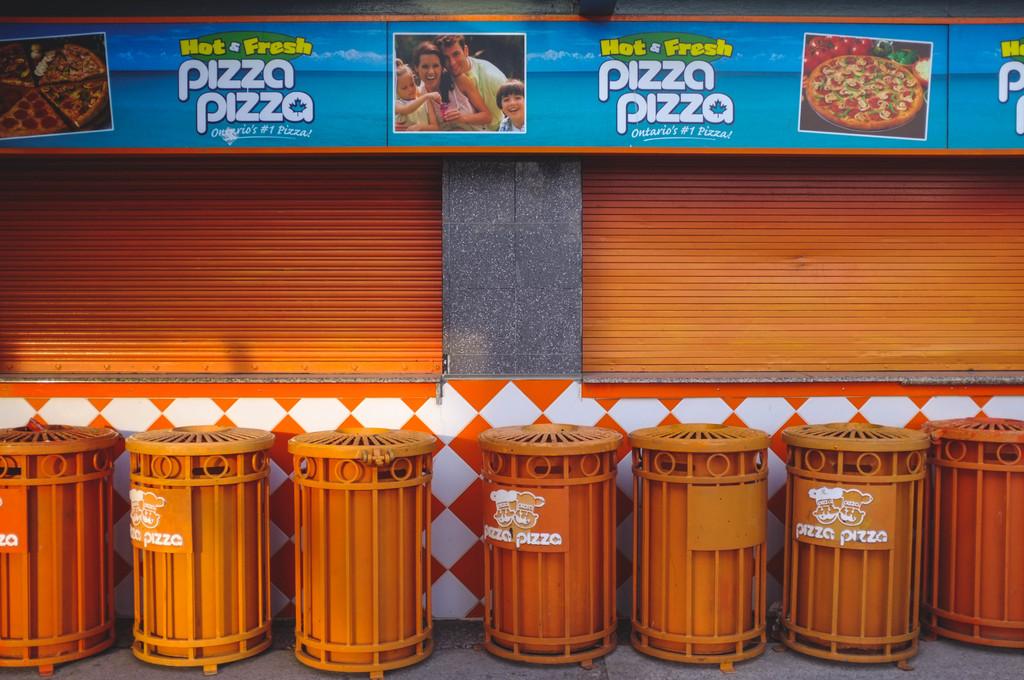What is served hot & fresh?
Provide a succinct answer. Pizza. 